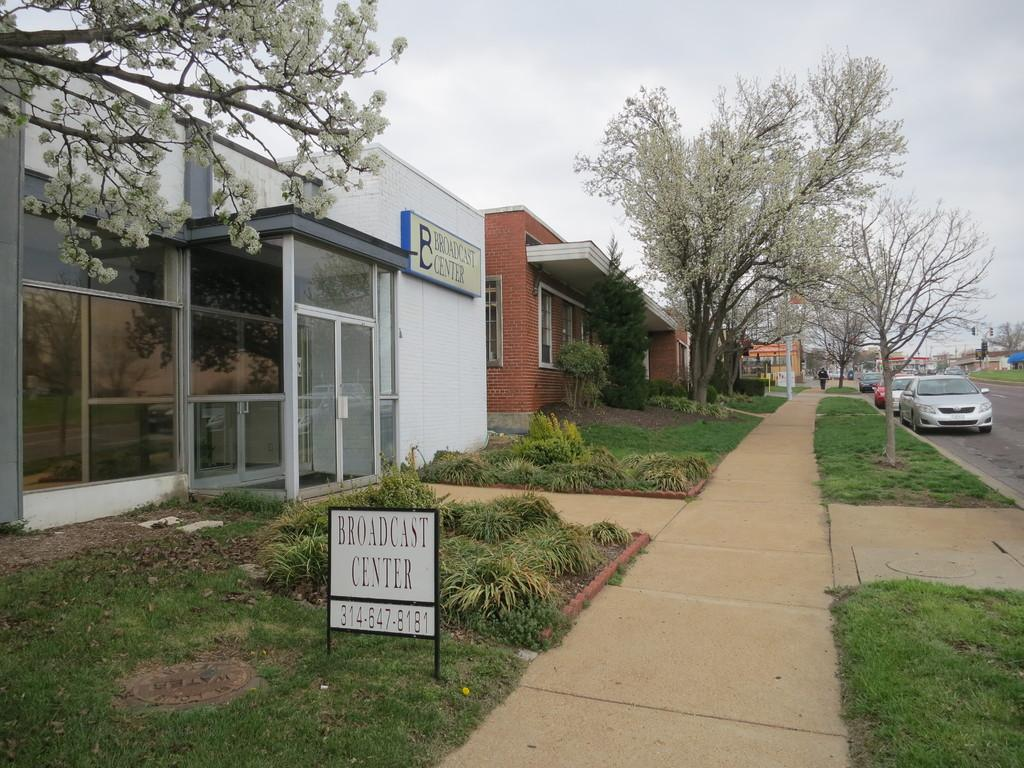What can be seen on the side of the road in the image? There are vehicles on the side of the road in the image. What is the person in the image doing? There is a person walking on the side of the road in the image. What structures can be seen in the image? There are buildings visible in the image. What type of vegetation is present in the image? There are trees in the image. Where is the station located in the image? There is no station present in the image. What type of birthday celebration is happening in the image? There is no birthday celebration present in the image. 